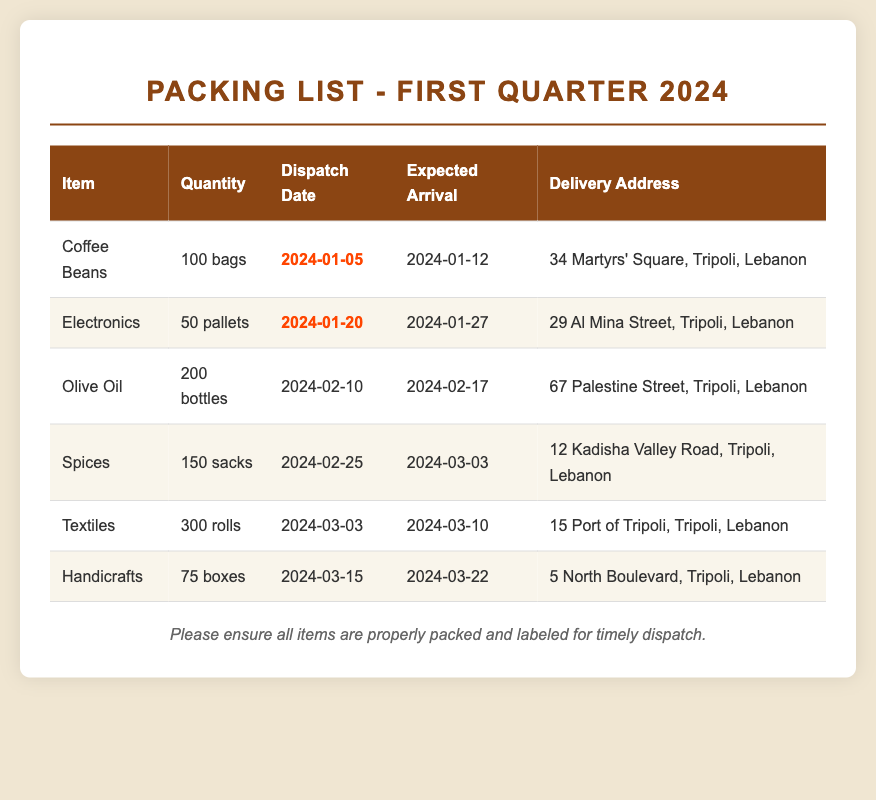What is the dispatch date for Coffee Beans? The dispatch date for Coffee Beans is listed in the table as 2024-01-05.
Answer: 2024-01-05 How many bags of Coffee Beans are being shipped? The quantity of Coffee Beans is specified as 100 bags in the document.
Answer: 100 bags What is the expected arrival date for the Electronics? The expected arrival date for the Electronics is provided as 2024-01-27.
Answer: 2024-01-27 Where is the delivery address for Handicrafts? The document states the delivery address for Handicrafts as 5 North Boulevard, Tripoli, Lebanon.
Answer: 5 North Boulevard, Tripoli, Lebanon Which item has the latest dispatch date? Reasoning through the dispatch dates, Handicrafts has the latest date of 2024-03-15.
Answer: Handicrafts What is the total quantity of Textiles being shipped? The document indicates that 300 rolls of Textiles are being shipped.
Answer: 300 rolls Which item is marked urgent in the packing list? The items Coffee Beans and Electronics are marked as urgent in their respective dispatch dates.
Answer: Coffee Beans, Electronics What is the delivery address for Olive Oil? The delivery address for Olive Oil is mentioned as 67 Palestine Street, Tripoli, Lebanon.
Answer: 67 Palestine Street, Tripoli, Lebanon When is the expected arrival for Spices? The expected arrival date for Spices is stated as 2024-03-03.
Answer: 2024-03-03 